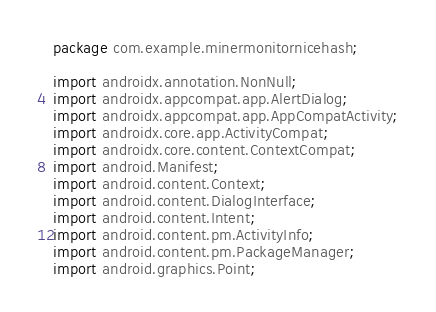Convert code to text. <code><loc_0><loc_0><loc_500><loc_500><_Java_>package com.example.minermonitornicehash;

import androidx.annotation.NonNull;
import androidx.appcompat.app.AlertDialog;
import androidx.appcompat.app.AppCompatActivity;
import androidx.core.app.ActivityCompat;
import androidx.core.content.ContextCompat;
import android.Manifest;
import android.content.Context;
import android.content.DialogInterface;
import android.content.Intent;
import android.content.pm.ActivityInfo;
import android.content.pm.PackageManager;
import android.graphics.Point;</code> 